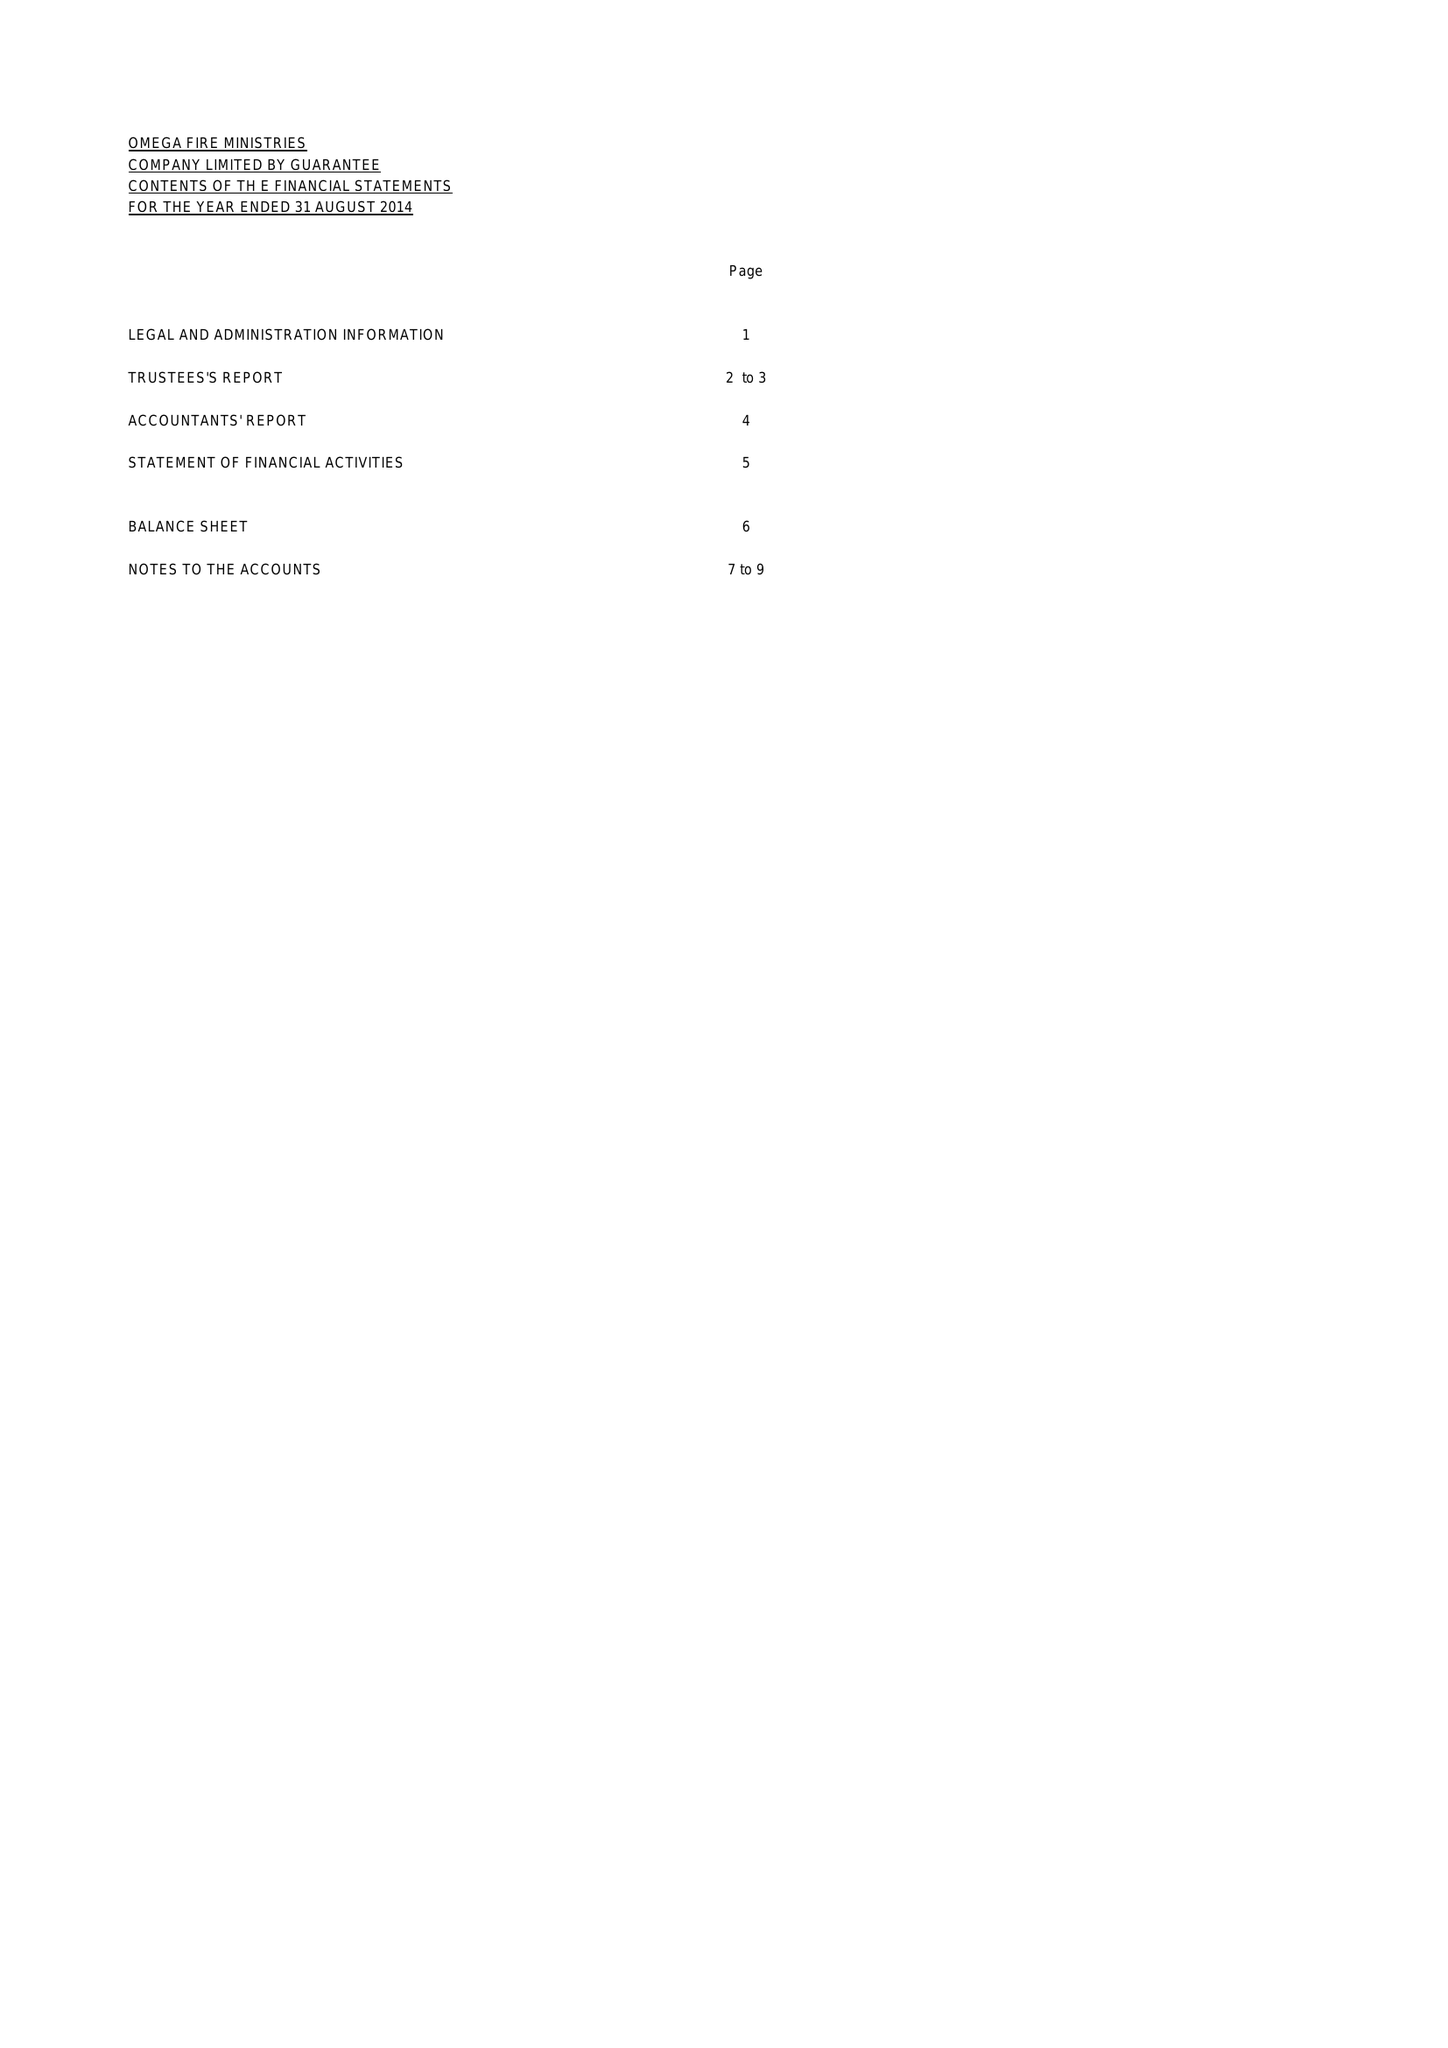What is the value for the spending_annually_in_british_pounds?
Answer the question using a single word or phrase. 24738.00 